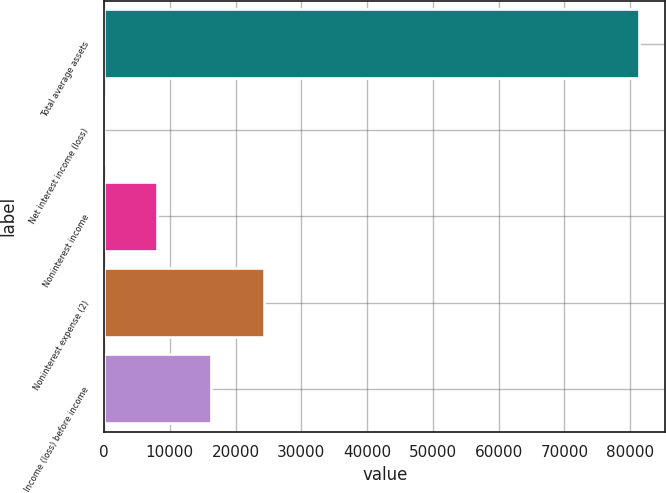Convert chart. <chart><loc_0><loc_0><loc_500><loc_500><bar_chart><fcel>Total average assets<fcel>Net interest income (loss)<fcel>Noninterest income<fcel>Noninterest expense (2)<fcel>Income (loss) before income<nl><fcel>81312<fcel>8<fcel>8138.4<fcel>24399.2<fcel>16268.8<nl></chart> 